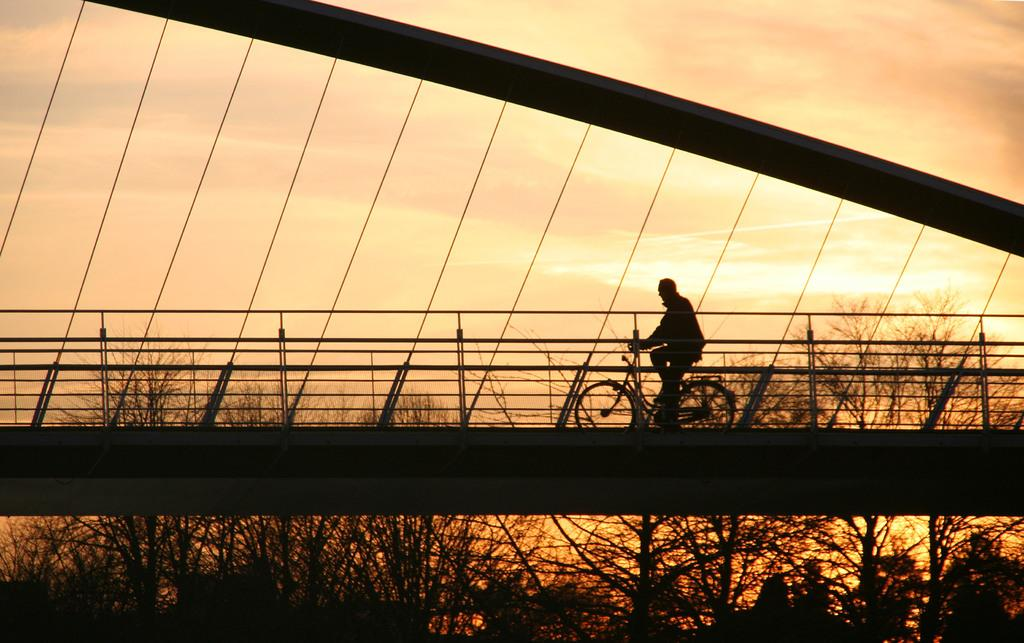What is the main subject of the image? There is a person riding a bicycle in the image. Where is the person riding the bicycle? The person is riding the bicycle on a bridge. What can be seen in the background of the image? There are trees visible in the image. How many hands does the pickle have in the image? There is no pickle present in the image, so it cannot be determined how many hands it might have. 